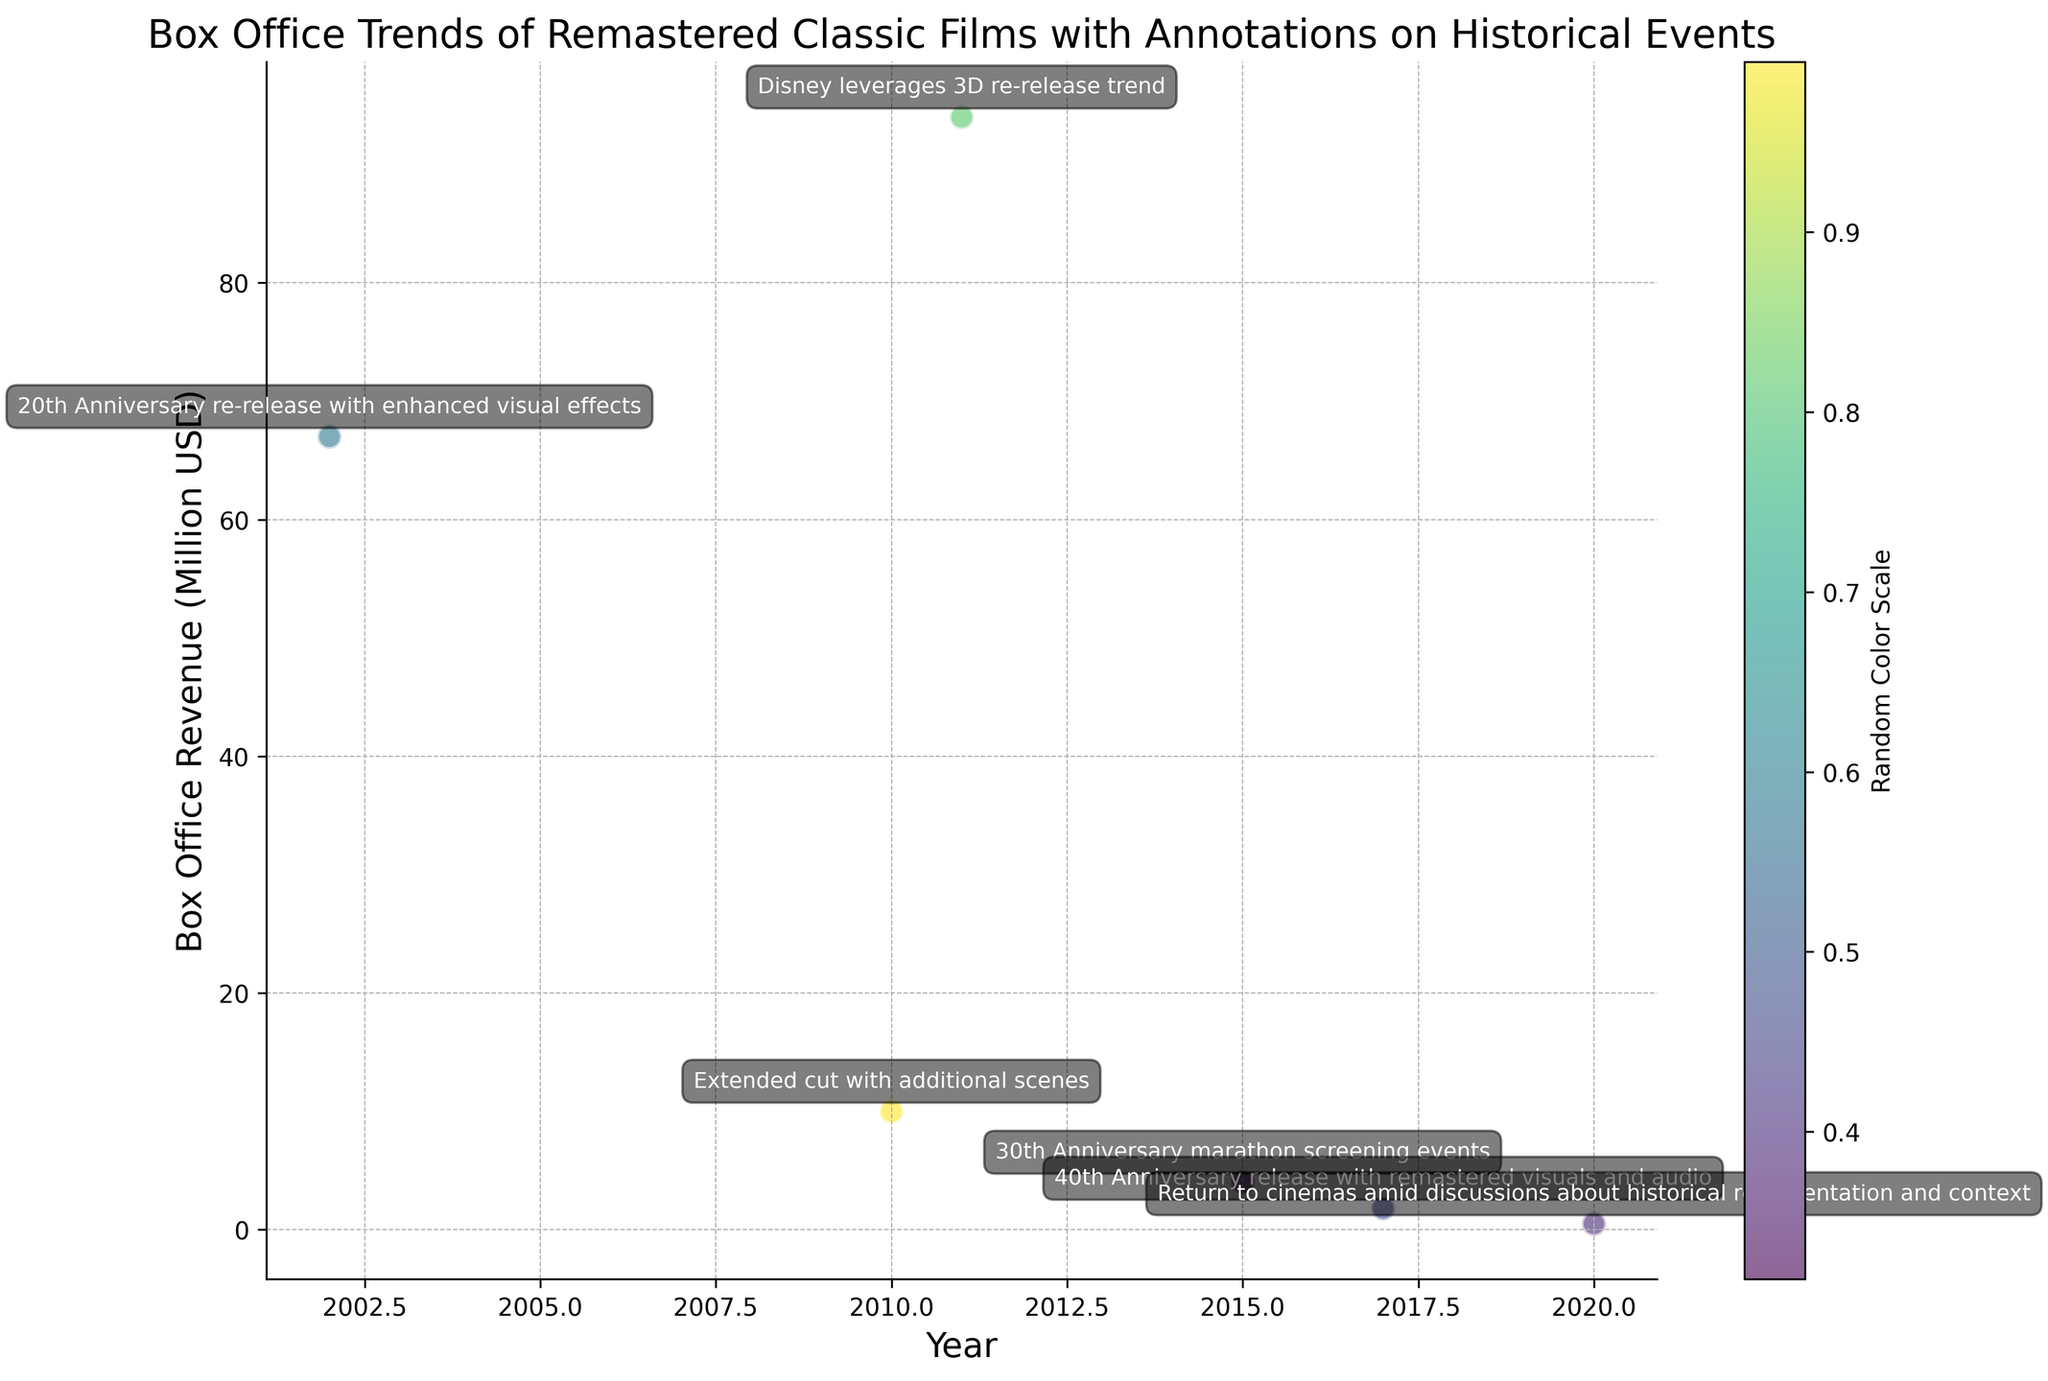Which re-released film had the highest box office revenue? To determine which re-released film had the highest revenue, examine the scatter plot and identify the point positioned highest on the y-axis, which is labeled "Box Office Revenue (Million USD)". The film associated with this point is "The Lion King (3D)" with a revenue of 94 million USD.
Answer: The Lion King (3D) What is the difference in box office revenue between the film with the highest revenue and the film with the lowest revenue? The film with the highest revenue is "The Lion King (3D)" with 94 million USD, and the film with the lowest revenue is "Gone with the Wind (Re-release)" with 0.5 million USD. The difference is 94 - 0.5.
Answer: 93.5 million USD Which film's re-release coincided with a major anniversary and earned less than 5 million USD? By looking at the annotations, identify films with major anniversaries and then check their box office revenue. "Back to the Future Trilogy" celebrated its 30th anniversary and earned 4 million USD.
Answer: Back to the Future Trilogy How many films had annotations related to anniversaries? Count the annotations mentioning anniversary events. The films with such annotations are "E.T. the Extra-Terrestrial (20th Anniversary)", "Back to the Future Trilogy (30th Anniversary)", and "Close Encounters of the Third Kind (40th Anniversary)". There are 3 such films.
Answer: 3 Which film released in 2002 had enhanced visual effects, and what was its box office revenue? Check the annotations for the film re-released in 2002. "E.T. the Extra-Terrestrial (20th Anniversary)" had enhanced visual effects. Its box office revenue is shown as 67 million USD.
Answer: E.T. the Extra-Terrestrial (20th Anniversary), 67 million USD What year had the highest sum of box office revenue from re-released films, and what is this sum? Add the box office revenues for each year. 2002: 67, 2010: 10, 2011: 94, 2015: 4, 2017: 1.8, 2020: 0.5. The year with the highest sum is 2011, with 94 million USD.
Answer: 2011, 94 million USD Which film had the most recent original release year and how much did it earn in the re-release? "Avatar (Extended Collector's Edition)" has the most recent original release year, 2009, and it earned 10 million USD.
Answer: Avatar (Extended Collector's Edition), 10 million USD What was the box office revenue for the re-released film that came out amid discussions about historical representation? Check the annotation mentioning discussions about historical representation. "Gone with the Wind (Re-release)" is linked with this context and earned 0.5 million USD.
Answer: 0.5 million USD Which films earned less than 10 million USD in their re-releases? Examine the scatter plot and find points positioned below the 10 million USD mark on the y-axis. These films are "Back to the Future Trilogy" (4 million USD), "Close Encounters of the Third Kind (40th Anniversary)" (1.8 million USD), and "Gone with the Wind (Re-release)" (0.5 million USD).
Answer: Back to the Future Trilogy, Close Encounters of the Third Kind (40th Anniversary), Gone with the Wind (Re-release) Which film's re-release leveraged the 3D re-release trend, and how much did it earn? Check the annotation mentioning leveraging the 3D re-release trend. "The Lion King (3D)" is tied to this context and earned 94 million USD.
Answer: The Lion King (3D), 94 million USD 